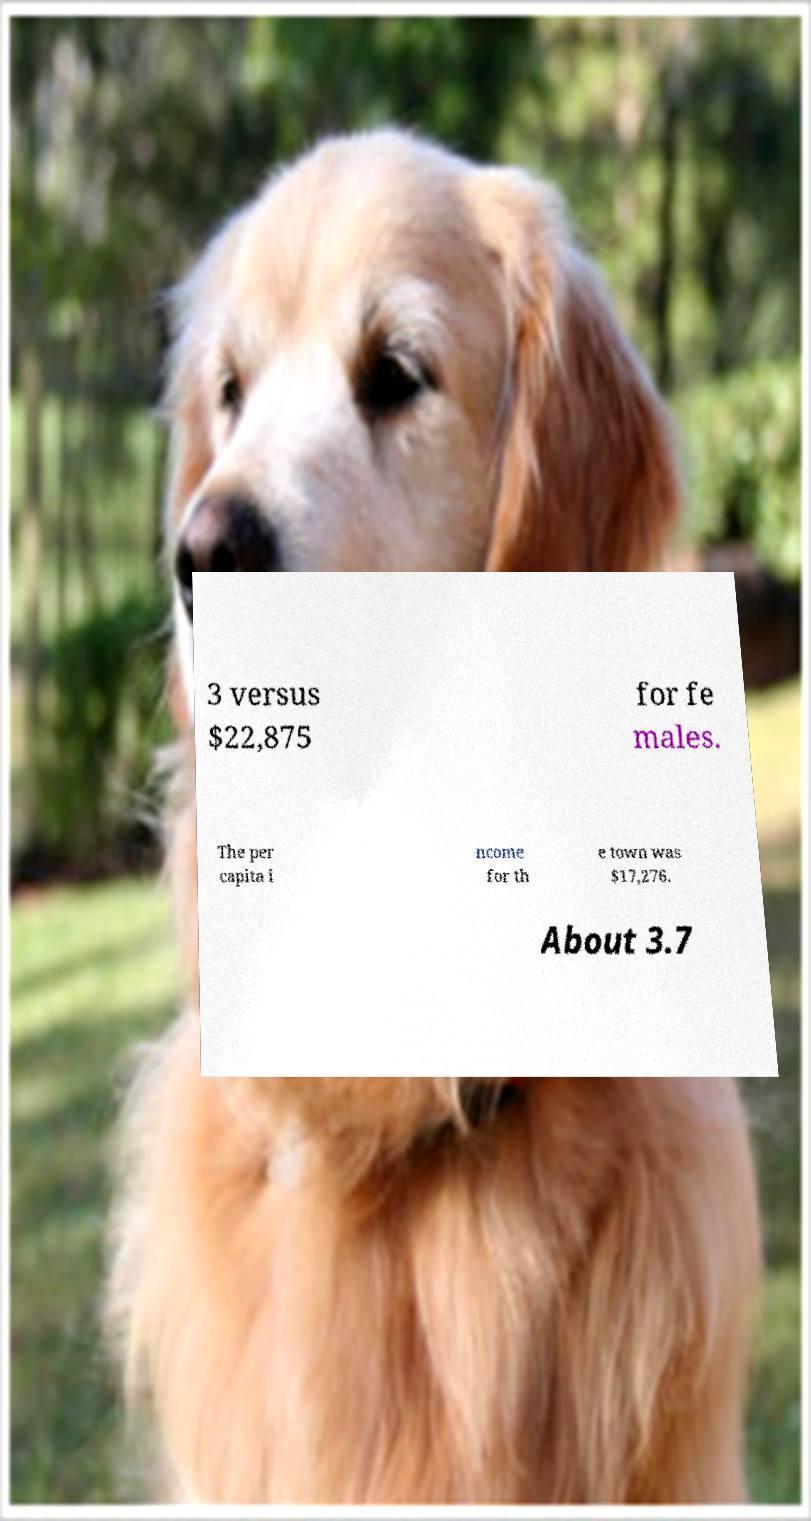Please read and relay the text visible in this image. What does it say? 3 versus $22,875 for fe males. The per capita i ncome for th e town was $17,276. About 3.7 